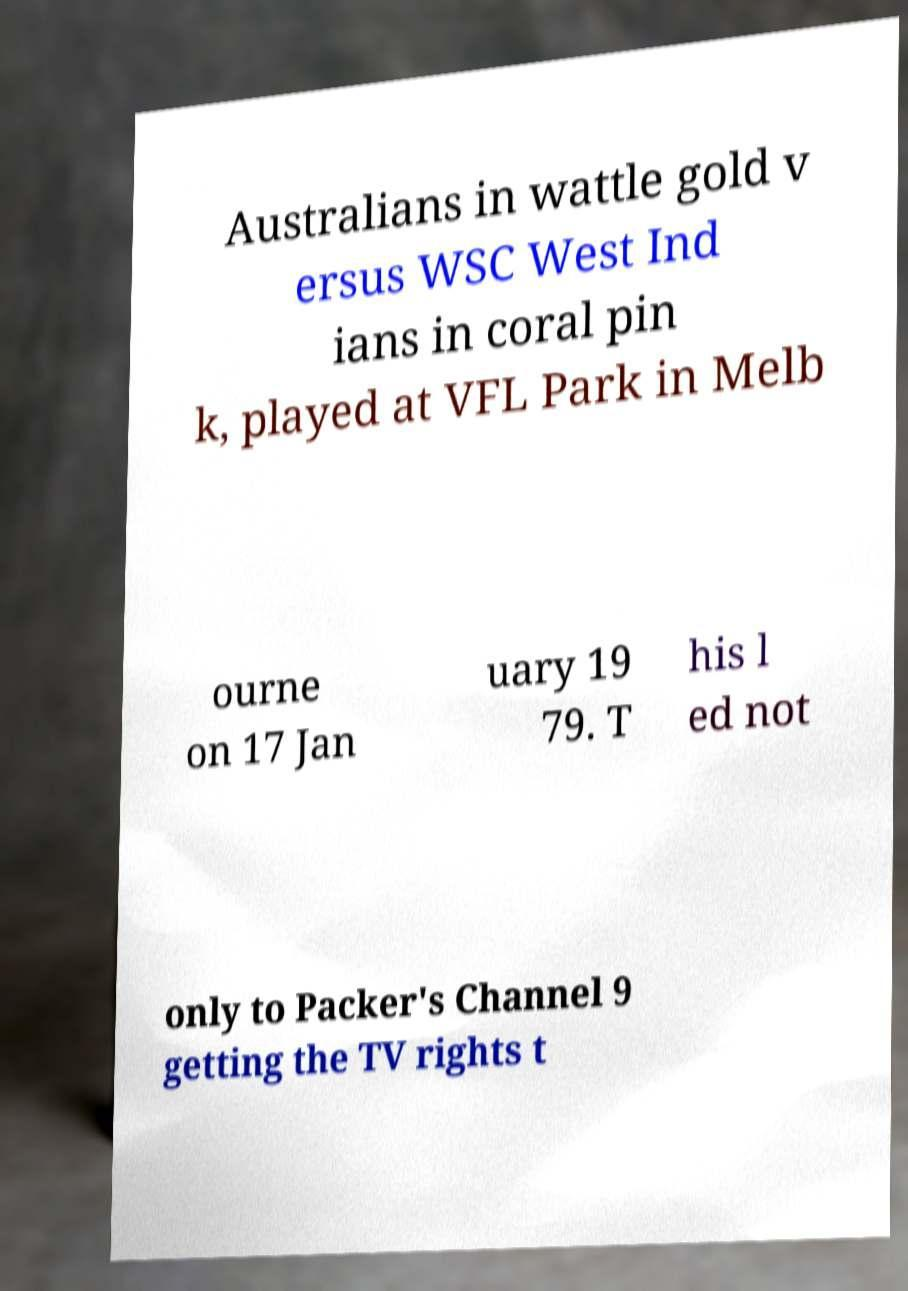Please read and relay the text visible in this image. What does it say? Australians in wattle gold v ersus WSC West Ind ians in coral pin k, played at VFL Park in Melb ourne on 17 Jan uary 19 79. T his l ed not only to Packer's Channel 9 getting the TV rights t 